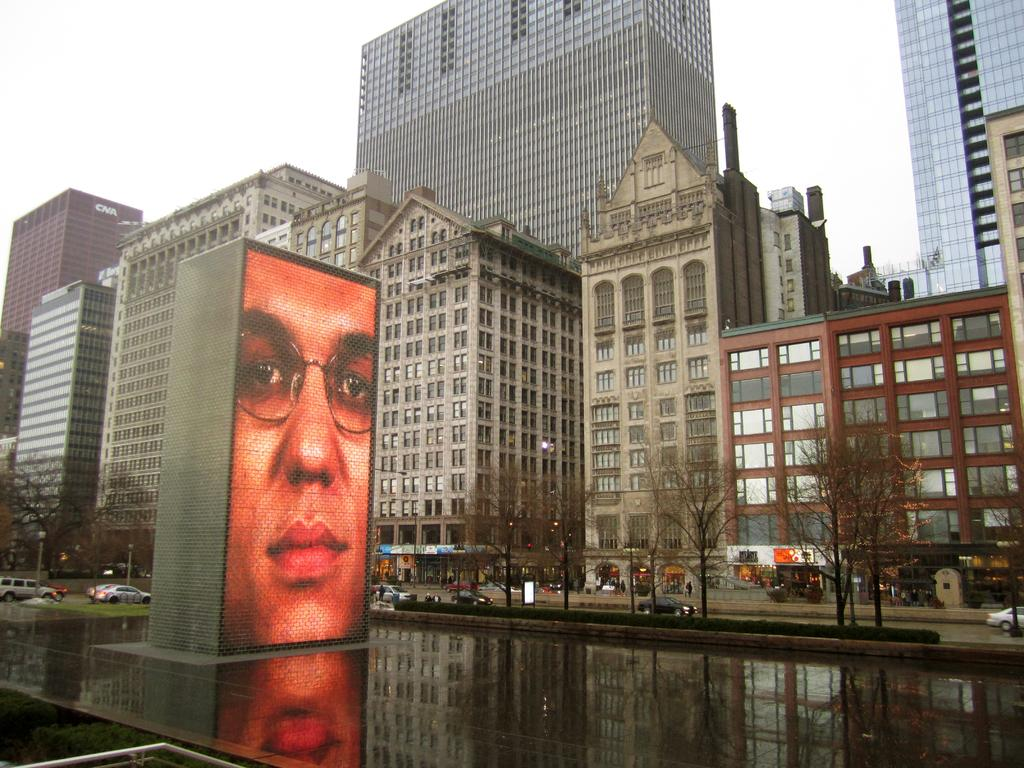What is located in the middle of the image? There is a water surface in the middle of the image. What is on the water surface? There is a fountain on the water surface. What can be seen in the background of the image? There are trees, cars on the road, buildings, and the sky visible in the background of the image. How many pins are attached to the fountain in the image? There are no pins present or attached to the fountain in the image. Can you tell me if the people in the image are swimming in the water? There are no people visible in the image, so it cannot be determined if anyone is swimming in the water. 